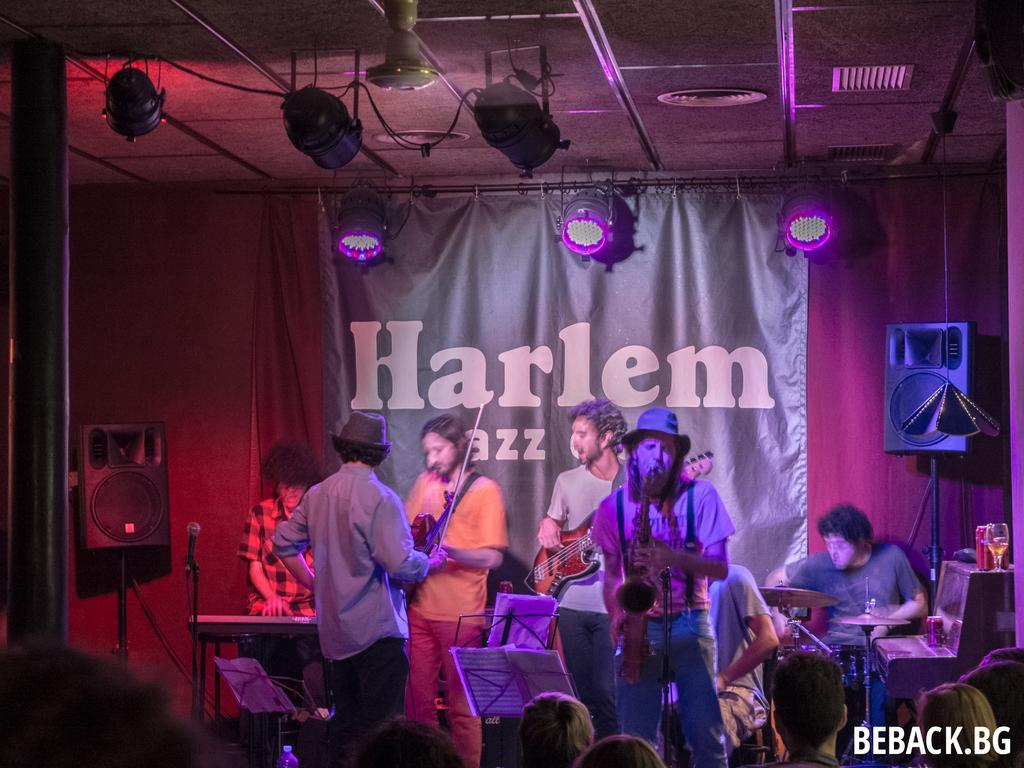Please provide a concise description of this image. In this image we can see people are playing musical instruments. Here we can see a mike, speakers, banner, cloth, wall, pole, lights, fan, and ceiling. At the bottom of the image we can see people and some text. 